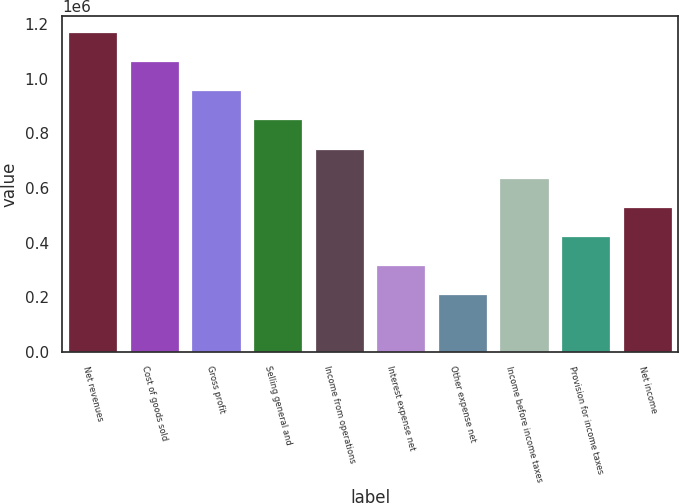Convert chart. <chart><loc_0><loc_0><loc_500><loc_500><bar_chart><fcel>Net revenues<fcel>Cost of goods sold<fcel>Gross profit<fcel>Selling general and<fcel>Income from operations<fcel>Interest expense net<fcel>Other expense net<fcel>Income before income taxes<fcel>Provision for income taxes<fcel>Net income<nl><fcel>1.17032e+06<fcel>1.06393e+06<fcel>957534<fcel>851142<fcel>744749<fcel>319179<fcel>212786<fcel>638357<fcel>425572<fcel>531964<nl></chart> 